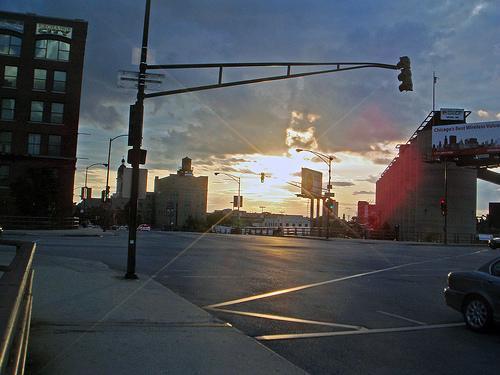How many cars on the road?
Give a very brief answer. 1. 